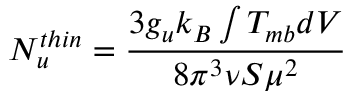<formula> <loc_0><loc_0><loc_500><loc_500>{ N _ { u } ^ { t h i n } } = \frac { 3 { g _ { u } } k _ { B } \int { T _ { m b } d V } } { 8 \pi ^ { 3 } \nu S \mu ^ { 2 } }</formula> 